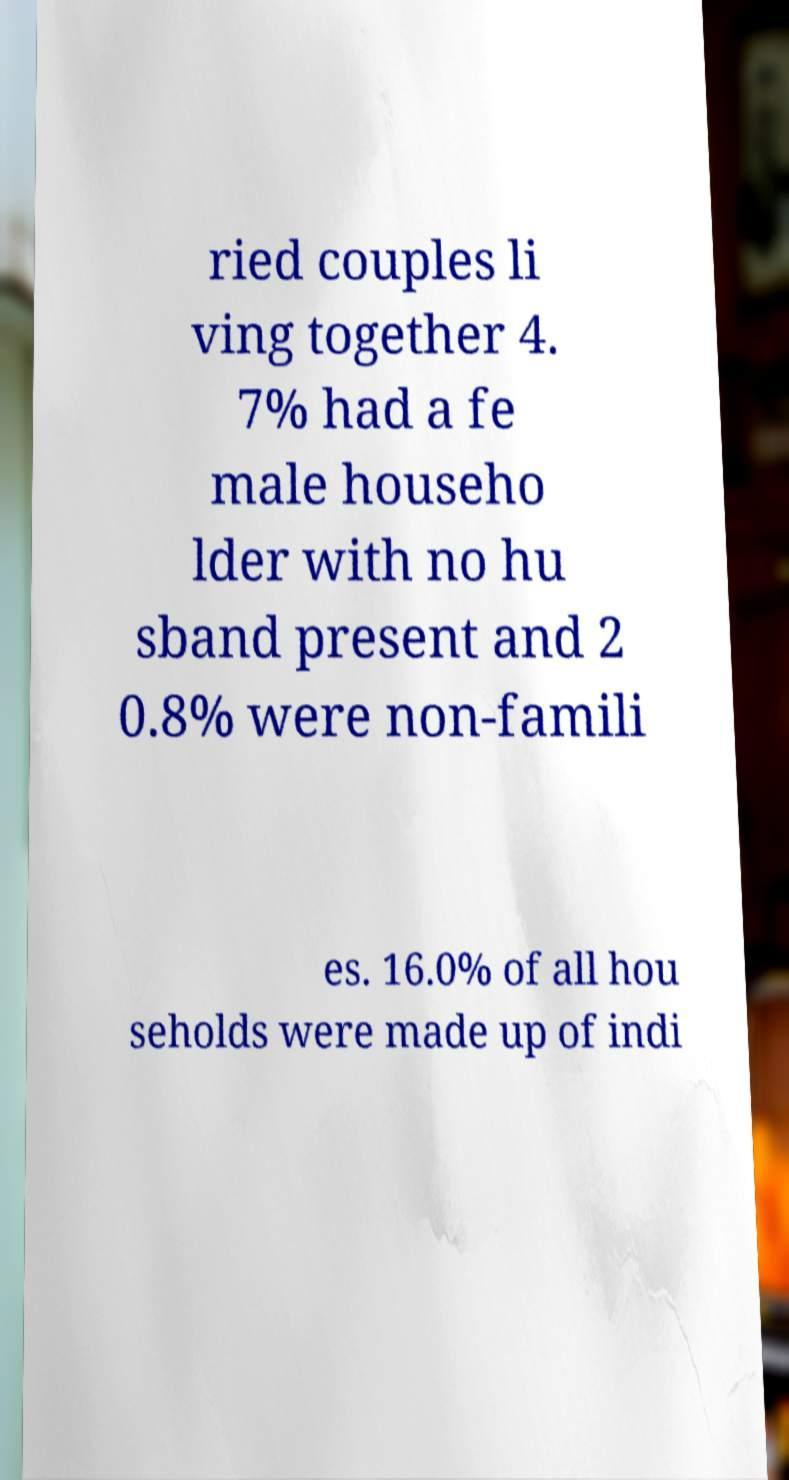There's text embedded in this image that I need extracted. Can you transcribe it verbatim? ried couples li ving together 4. 7% had a fe male househo lder with no hu sband present and 2 0.8% were non-famili es. 16.0% of all hou seholds were made up of indi 